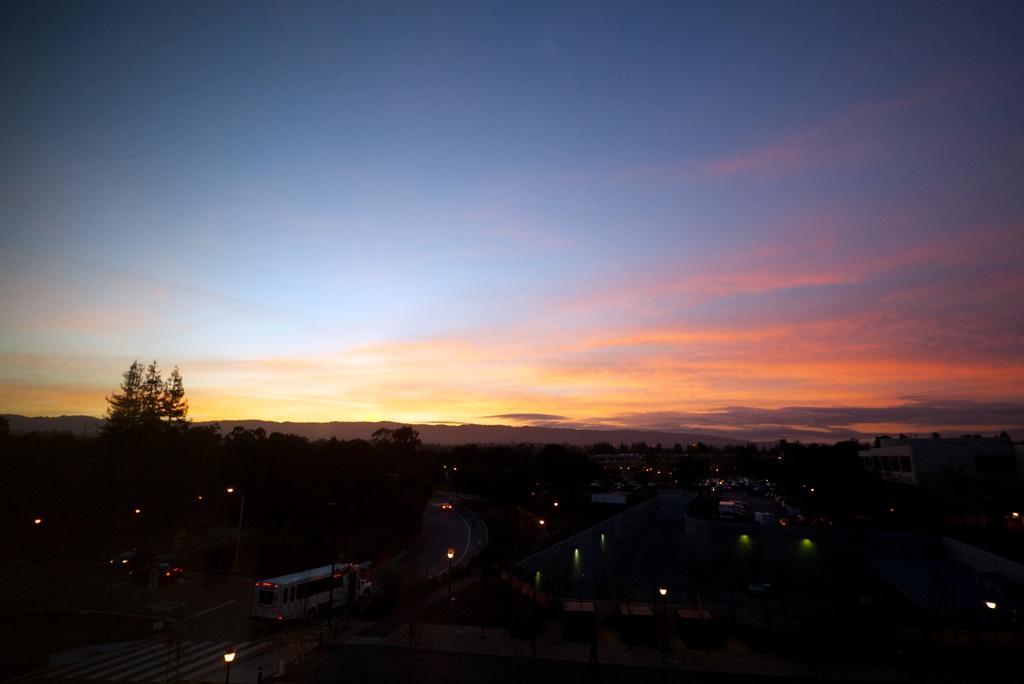How would you summarize this image in a sentence or two? In this picture I can see trees, buildings and few vehicles on the roads and I can see lights and a blue cloudy sky. 